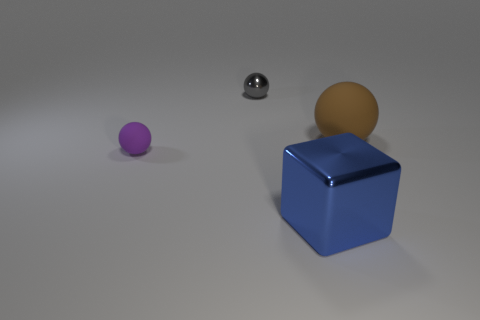Are there any shiny balls of the same size as the block?
Make the answer very short. No. There is a brown sphere that is the same size as the blue block; what is it made of?
Your answer should be compact. Rubber. There is a brown ball; is it the same size as the metallic object that is behind the tiny matte object?
Your answer should be very brief. No. What is the ball in front of the big brown thing made of?
Ensure brevity in your answer.  Rubber. Are there the same number of balls on the left side of the big brown rubber sphere and shiny cubes?
Provide a succinct answer. No. Does the purple rubber sphere have the same size as the shiny sphere?
Provide a succinct answer. Yes. Is there a large brown thing to the left of the metallic thing behind the ball that is right of the large blue object?
Provide a succinct answer. No. There is a brown thing that is the same shape as the tiny gray thing; what is its material?
Ensure brevity in your answer.  Rubber. How many big spheres are behind the matte object to the left of the tiny gray object?
Give a very brief answer. 1. What size is the matte object that is behind the matte thing in front of the matte object on the right side of the big block?
Give a very brief answer. Large. 